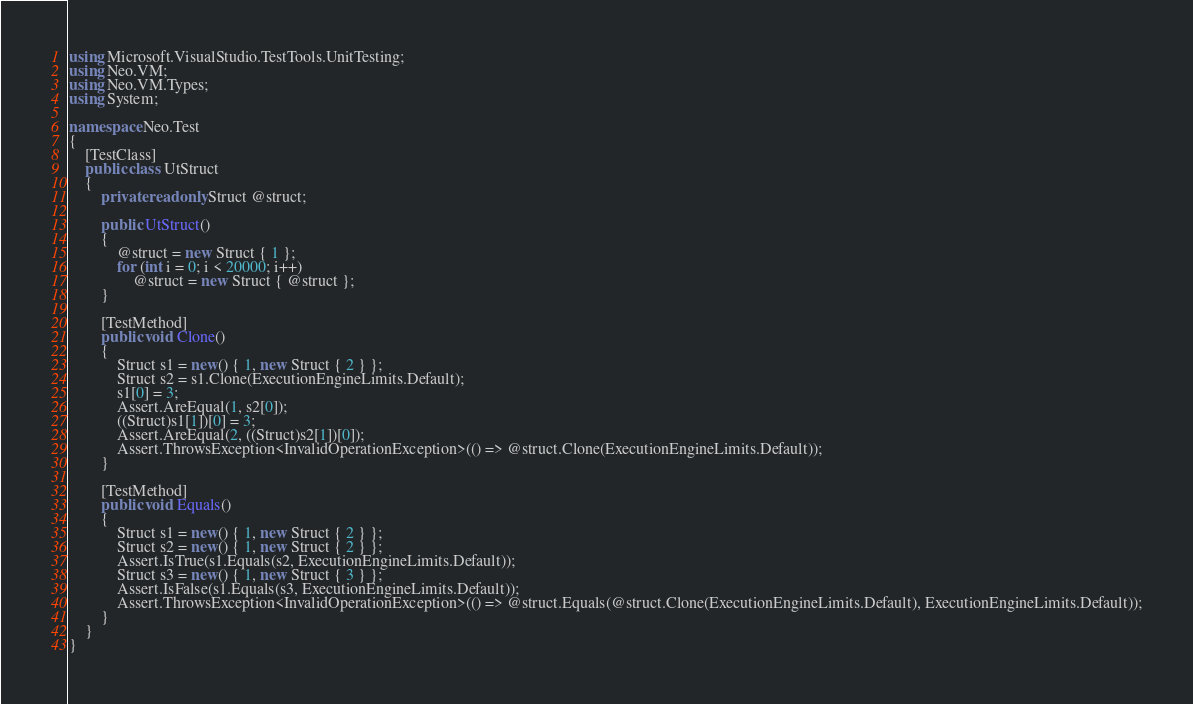Convert code to text. <code><loc_0><loc_0><loc_500><loc_500><_C#_>using Microsoft.VisualStudio.TestTools.UnitTesting;
using Neo.VM;
using Neo.VM.Types;
using System;

namespace Neo.Test
{
    [TestClass]
    public class UtStruct
    {
        private readonly Struct @struct;

        public UtStruct()
        {
            @struct = new Struct { 1 };
            for (int i = 0; i < 20000; i++)
                @struct = new Struct { @struct };
        }

        [TestMethod]
        public void Clone()
        {
            Struct s1 = new() { 1, new Struct { 2 } };
            Struct s2 = s1.Clone(ExecutionEngineLimits.Default);
            s1[0] = 3;
            Assert.AreEqual(1, s2[0]);
            ((Struct)s1[1])[0] = 3;
            Assert.AreEqual(2, ((Struct)s2[1])[0]);
            Assert.ThrowsException<InvalidOperationException>(() => @struct.Clone(ExecutionEngineLimits.Default));
        }

        [TestMethod]
        public void Equals()
        {
            Struct s1 = new() { 1, new Struct { 2 } };
            Struct s2 = new() { 1, new Struct { 2 } };
            Assert.IsTrue(s1.Equals(s2, ExecutionEngineLimits.Default));
            Struct s3 = new() { 1, new Struct { 3 } };
            Assert.IsFalse(s1.Equals(s3, ExecutionEngineLimits.Default));
            Assert.ThrowsException<InvalidOperationException>(() => @struct.Equals(@struct.Clone(ExecutionEngineLimits.Default), ExecutionEngineLimits.Default));
        }
    }
}
</code> 